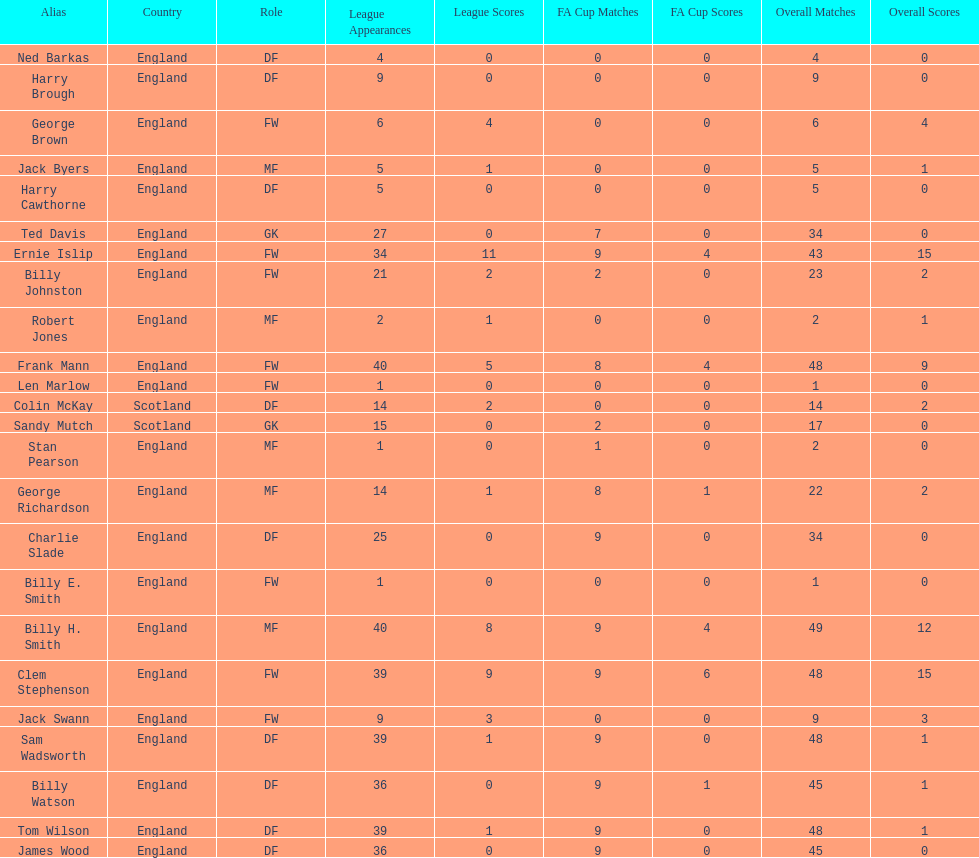Average number of goals scored by players from scotland 1. 